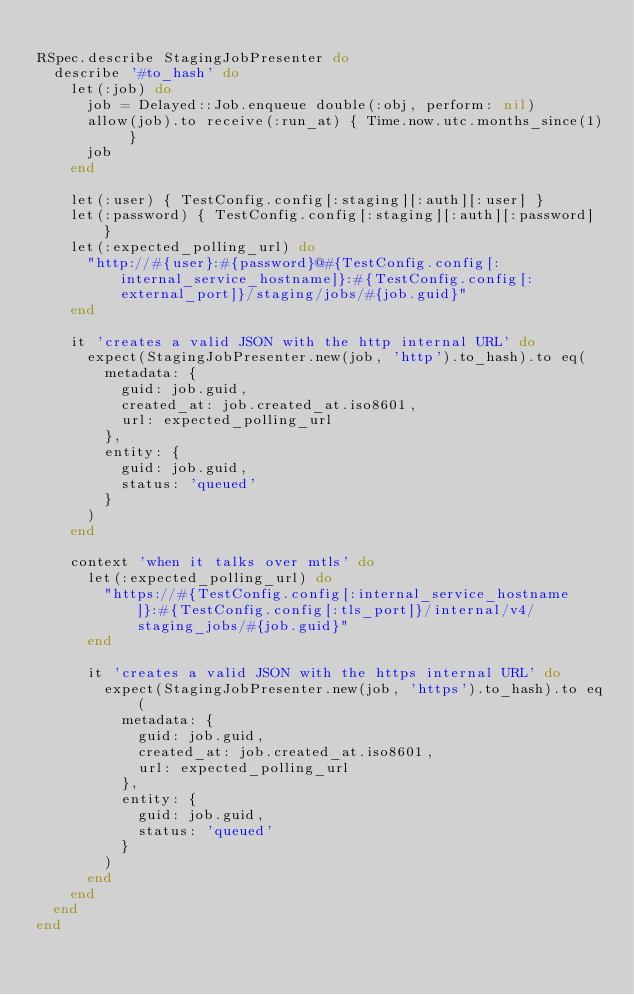Convert code to text. <code><loc_0><loc_0><loc_500><loc_500><_Ruby_>
RSpec.describe StagingJobPresenter do
  describe '#to_hash' do
    let(:job) do
      job = Delayed::Job.enqueue double(:obj, perform: nil)
      allow(job).to receive(:run_at) { Time.now.utc.months_since(1) }
      job
    end

    let(:user) { TestConfig.config[:staging][:auth][:user] }
    let(:password) { TestConfig.config[:staging][:auth][:password] }
    let(:expected_polling_url) do
      "http://#{user}:#{password}@#{TestConfig.config[:internal_service_hostname]}:#{TestConfig.config[:external_port]}/staging/jobs/#{job.guid}"
    end

    it 'creates a valid JSON with the http internal URL' do
      expect(StagingJobPresenter.new(job, 'http').to_hash).to eq(
        metadata: {
          guid: job.guid,
          created_at: job.created_at.iso8601,
          url: expected_polling_url
        },
        entity: {
          guid: job.guid,
          status: 'queued'
        }
      )
    end

    context 'when it talks over mtls' do
      let(:expected_polling_url) do
        "https://#{TestConfig.config[:internal_service_hostname]}:#{TestConfig.config[:tls_port]}/internal/v4/staging_jobs/#{job.guid}"
      end

      it 'creates a valid JSON with the https internal URL' do
        expect(StagingJobPresenter.new(job, 'https').to_hash).to eq(
          metadata: {
            guid: job.guid,
            created_at: job.created_at.iso8601,
            url: expected_polling_url
          },
          entity: {
            guid: job.guid,
            status: 'queued'
          }
        )
      end
    end
  end
end
</code> 